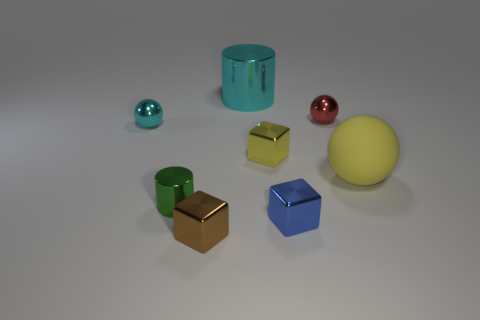Add 2 yellow metallic things. How many objects exist? 10 Subtract all blocks. How many objects are left? 5 Subtract all cyan cylinders. Subtract all big cyan things. How many objects are left? 6 Add 3 tiny metallic balls. How many tiny metallic balls are left? 5 Add 4 small metallic blocks. How many small metallic blocks exist? 7 Subtract 0 gray cylinders. How many objects are left? 8 